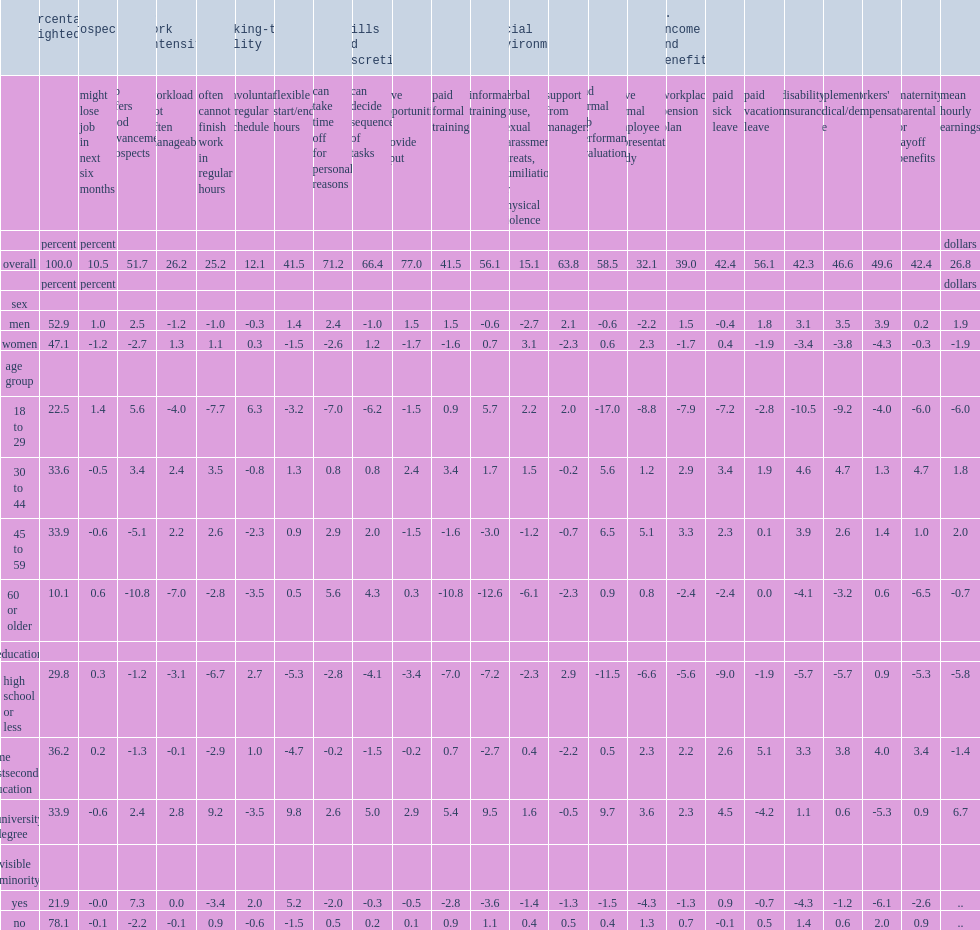For education,who were least likely to be recognized for their work efforts given the low access to performance evaluation? High school or less. For age group,who were most likely to be in a job with irregular work schedules? 18 to 29. Who earned less in hourly wages,female or male? Women. 